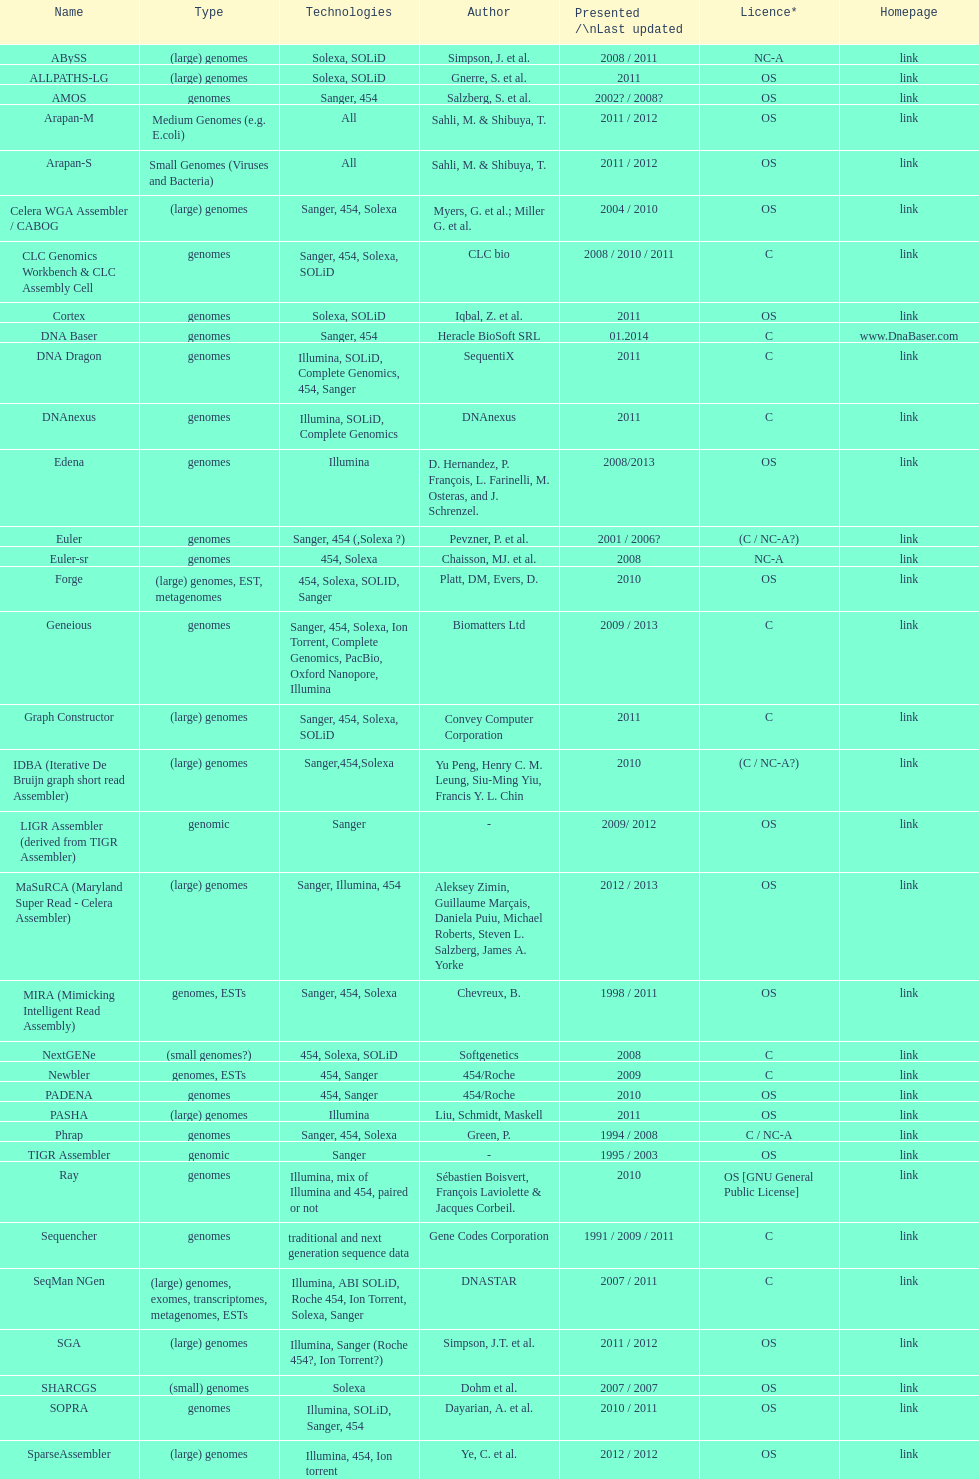What is the count of sahi, m. and shilbuya, t. being co-authors on publications? 2. 